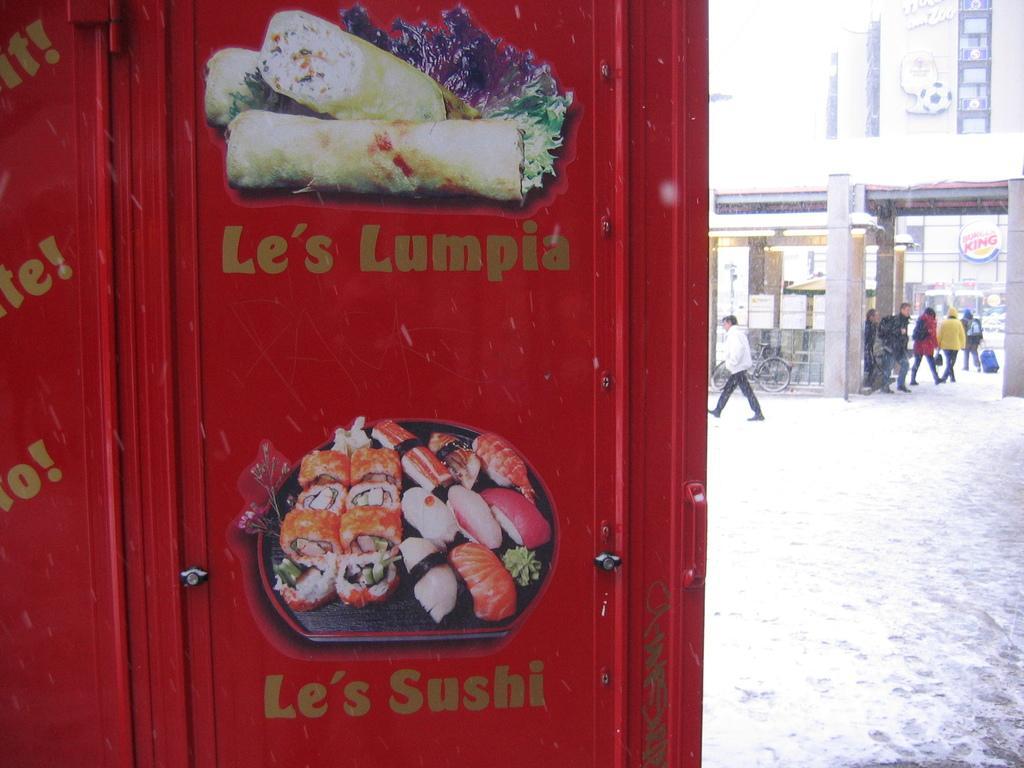Can you describe this image briefly? In this picture we can see a board, on this board we can see food, some text on it and in the background we can see people, bicycle on the road, here we can see a fence, pillars, buildings, name boards and some objects. 